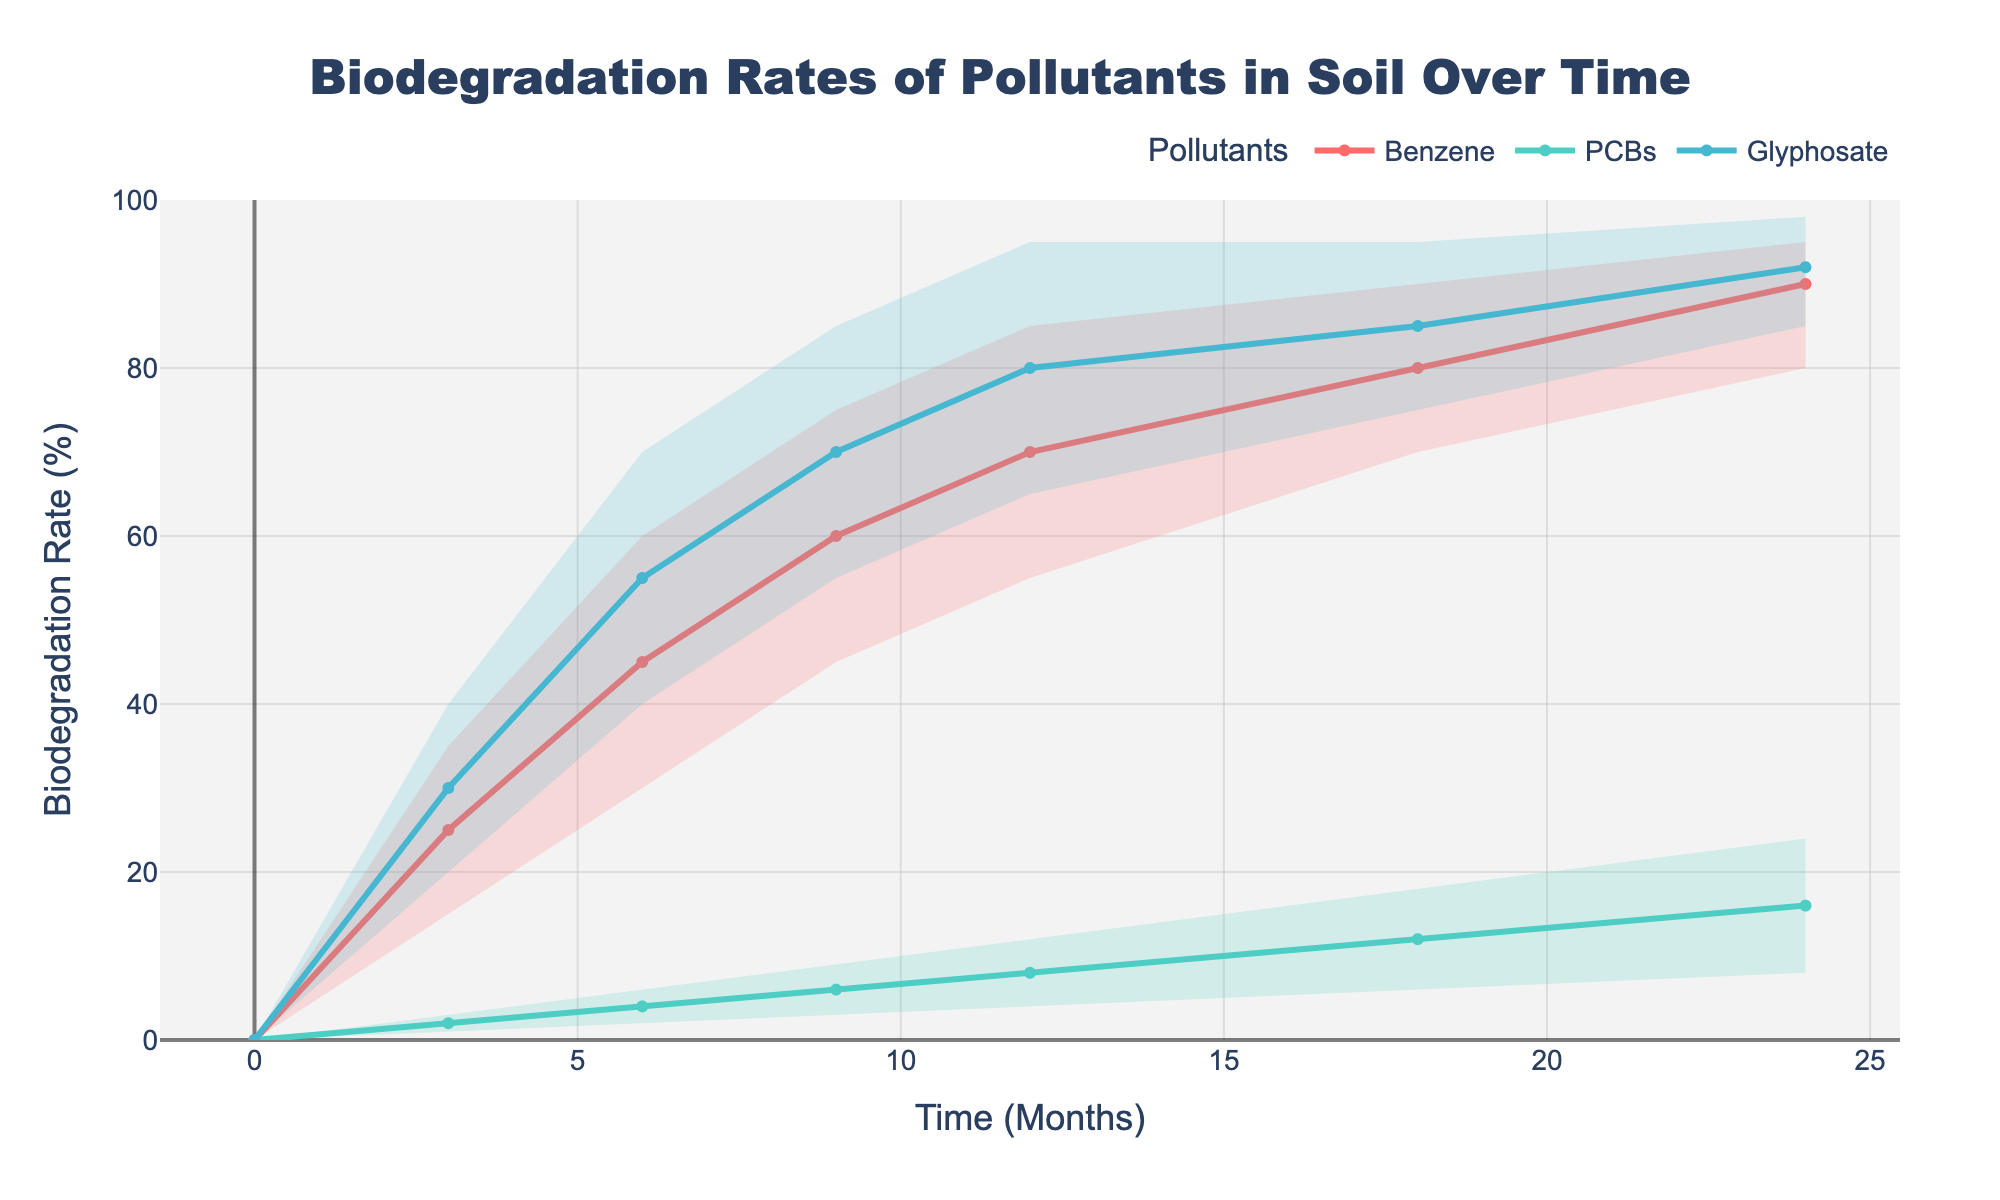What's the title of the figure? The title of the figure is usually displayed at the top of the chart. In this case, it is written in large, bold letters to stand out.
Answer: Biodegradation Rates of Pollutants in Soil Over Time What are the labels on the x-axis and y-axis? The labels on the axes provide information about the variables being plotted. The label for the x-axis indicates "Time (Months)" and the label for the y-axis indicates "Biodegradation Rate (%)".
Answer: Time (Months) and Biodegradation Rate (%) How does the median biodegradation rate of Benzene change from 0 to 24 months? To find this, look at the median biodegradation rate for Benzene at 0, 3, 6, 9, 12, 18, and 24 months. The change can be observed from these points on the chart.
Answer: It increases from 0% to 90% Compare the range of biodegradation rates for PCBs and Glyphosate at 12 months. To compare the ranges, observe the high and low values for PCBs and Glyphosate at 12 months. PCBs range from 4% to 12%, while Glyphosate ranges from 65% to 95%.
Answer: Glyphosate has a higher range compared to PCBs Which pollutant shows the least variability in biodegradation rate over time? Looking at the spread between the high and low values for each pollutant over time, PCBs have the least variability as their range remains narrow compared to Benzene and Glyphosate.
Answer: PCBs What is the biodegradation rate of Glyphosate at 24 months? Identify the median line for Glyphosate and locate the value at 24 months. The median value represents the biodegradation rate for Glyphosate at 24 months.
Answer: 92% What is the difference between the highest and lowest biodegradation rates of Benzene at 9 months? Observe the high and low values for Benzene at 9 months. The highest rate is 75% and the lowest rate is 45%. The difference is calculated by subtracting the lowest rate from the highest rate.
Answer: 30% By how much did the median biodegradation rate of PCBs increase from 0 to 24 months? Look at the median biodegradation rate of PCBs at 0 and 24 months. At 0 months, it's 0%; at 24 months, it's 16%. The increase is the difference between these values.
Answer: 16% Which pollutant shows the fastest initial increase in biodegradation rate within the first 3 months? Compare the changes in biodegradation rates from 0 to 3 months for all pollutants. Benzene increases to 25%, PCBs to 2%, and Glyphosate to 30%. Glyphosate shows the largest initial increase.
Answer: Glyphosate Is there any instance where the biodegradation rate of Glyphosate is lower than that of Benzene? Compare the values for Glyphosate and Benzene across all time points. Glyphosate always has a higher biodegradation rate than Benzene throughout the entire period.
Answer: No 